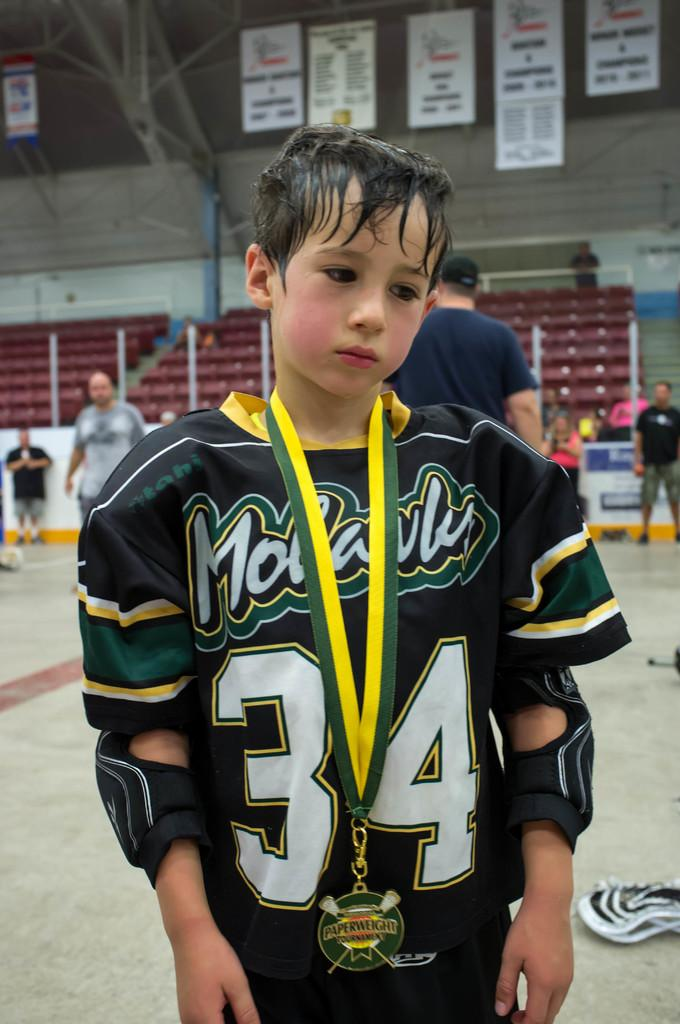<image>
Create a compact narrative representing the image presented. The kid here is wearing the number 34 on his jersey 